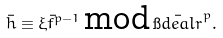Convert formula to latex. <formula><loc_0><loc_0><loc_500><loc_500>\bar { h } \equiv \xi \bar { f } ^ { p - 1 } \, \text {mod} \, \bar { \i d e a l { r } } ^ { p } .</formula> 